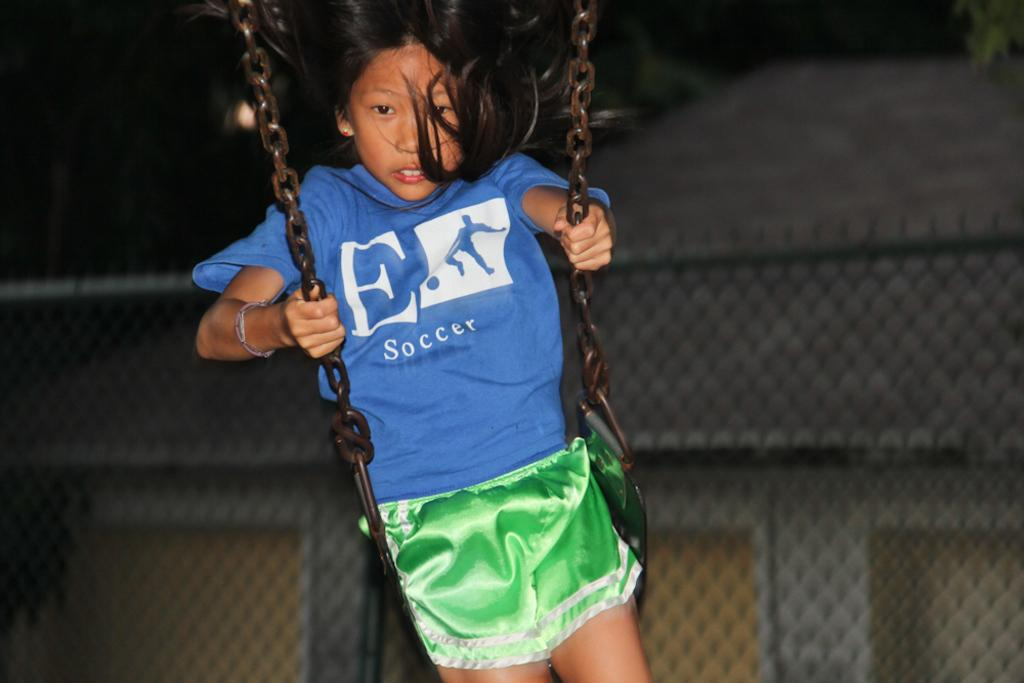<image>
Create a compact narrative representing the image presented. A young boy on a swing with the word soccer on his tee shirt. 